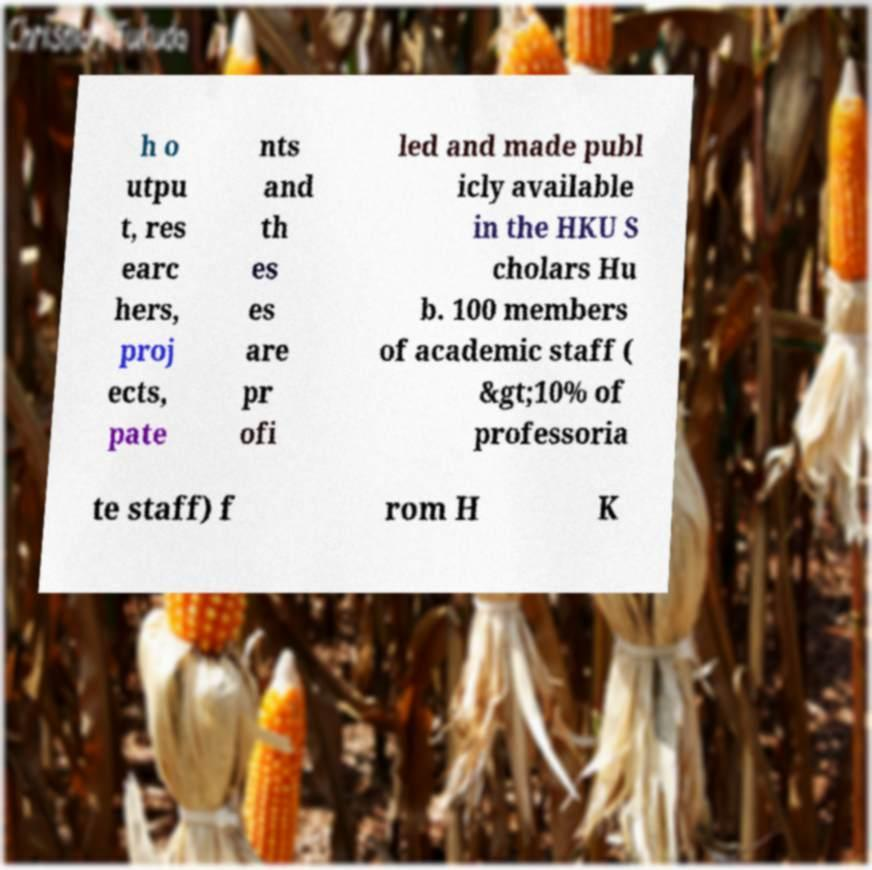Can you read and provide the text displayed in the image?This photo seems to have some interesting text. Can you extract and type it out for me? h o utpu t, res earc hers, proj ects, pate nts and th es es are pr ofi led and made publ icly available in the HKU S cholars Hu b. 100 members of academic staff ( &gt;10% of professoria te staff) f rom H K 